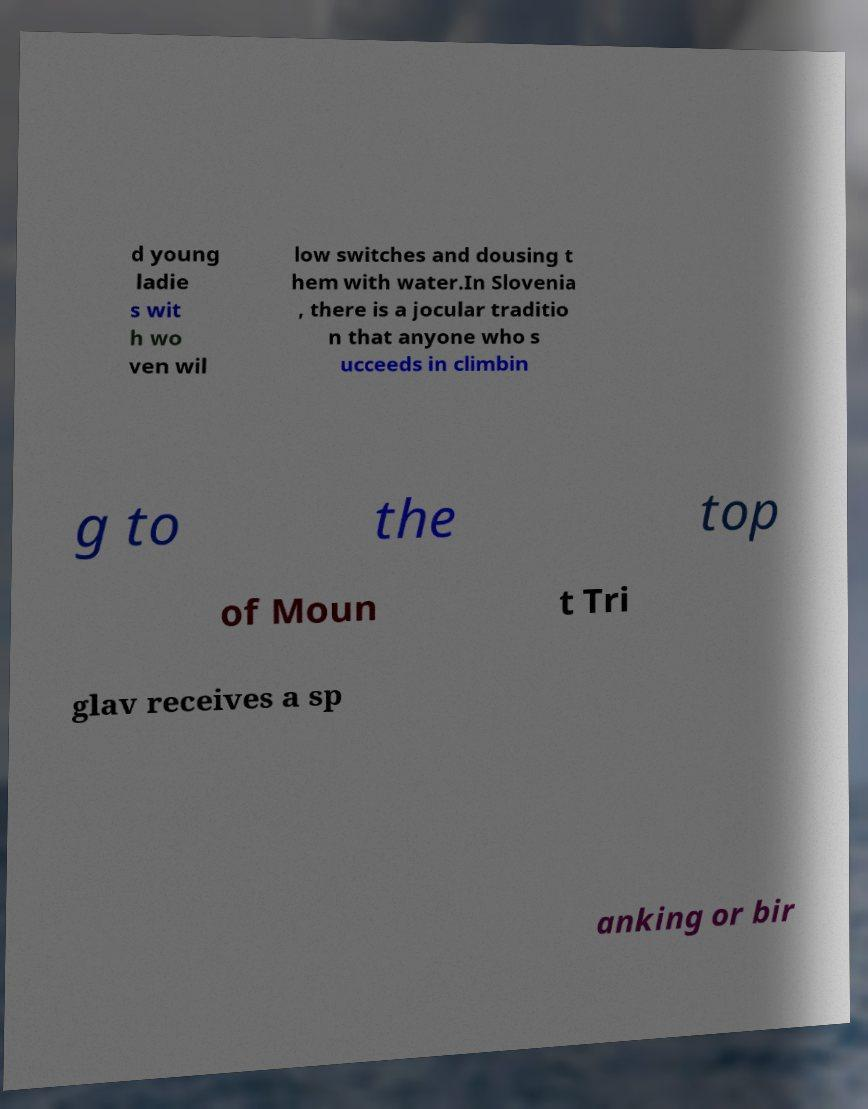What messages or text are displayed in this image? I need them in a readable, typed format. d young ladie s wit h wo ven wil low switches and dousing t hem with water.In Slovenia , there is a jocular traditio n that anyone who s ucceeds in climbin g to the top of Moun t Tri glav receives a sp anking or bir 